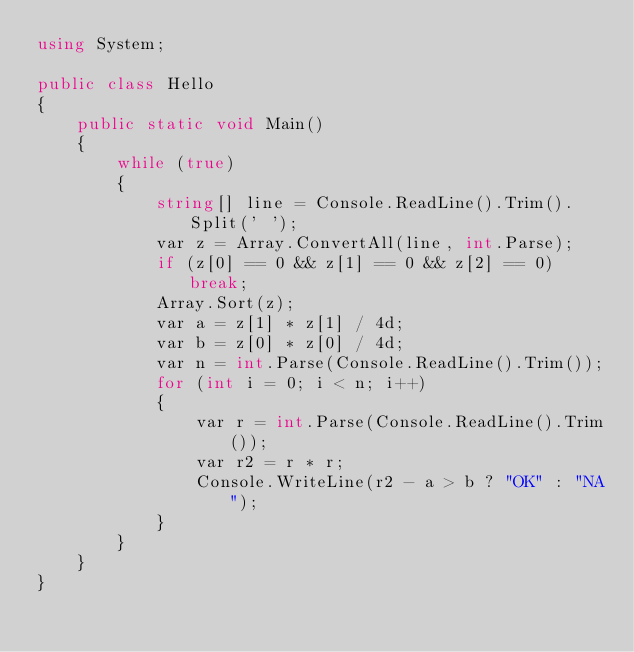Convert code to text. <code><loc_0><loc_0><loc_500><loc_500><_C#_>using System;

public class Hello
{
    public static void Main()
    {
        while (true)
        {
            string[] line = Console.ReadLine().Trim().Split(' ');
            var z = Array.ConvertAll(line, int.Parse);
            if (z[0] == 0 && z[1] == 0 && z[2] == 0) break;
            Array.Sort(z);
            var a = z[1] * z[1] / 4d;
            var b = z[0] * z[0] / 4d;
            var n = int.Parse(Console.ReadLine().Trim());
            for (int i = 0; i < n; i++)
            {
                var r = int.Parse(Console.ReadLine().Trim());
                var r2 = r * r;
                Console.WriteLine(r2 - a > b ? "OK" : "NA");
            }
        }
    }
}</code> 